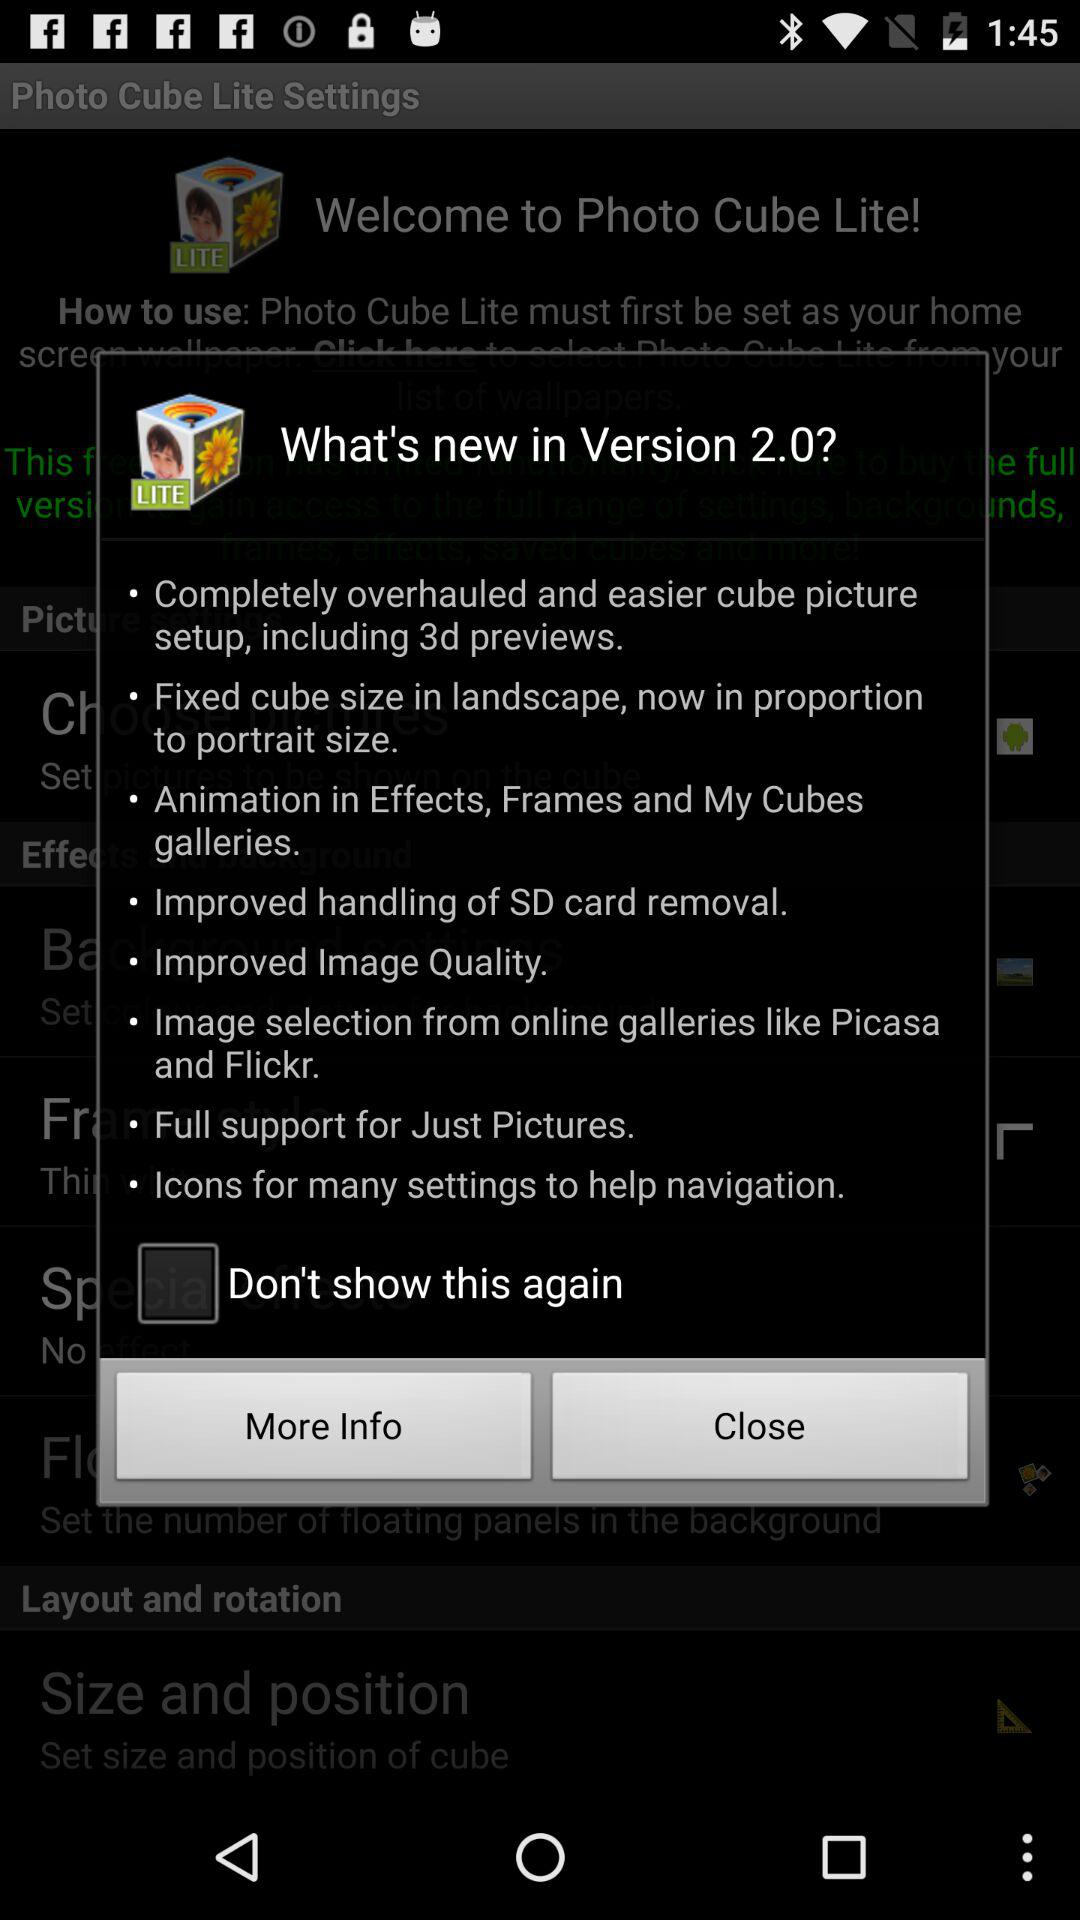What's the New Version number?
When the provided information is insufficient, respond with <no answer>. <no answer> 